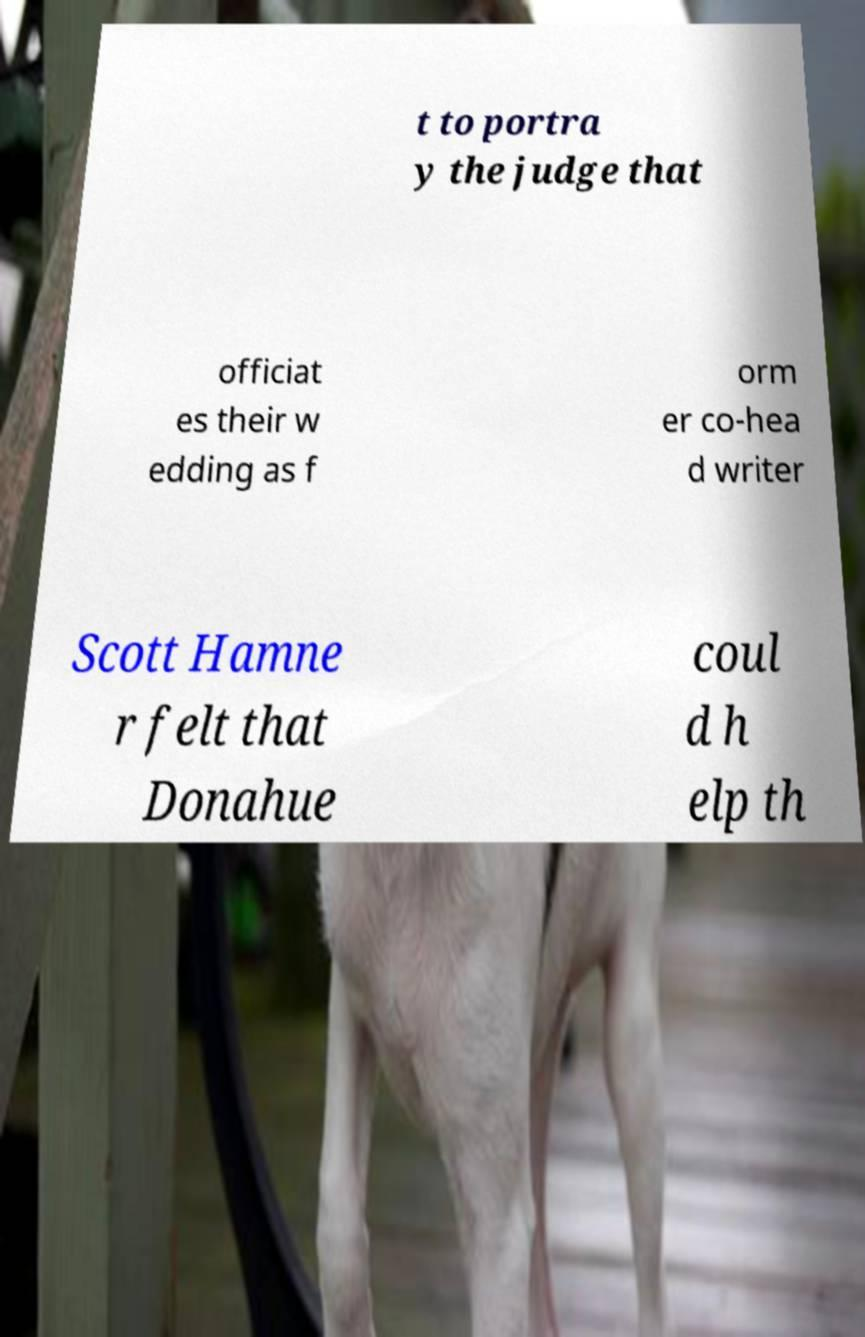Could you assist in decoding the text presented in this image and type it out clearly? t to portra y the judge that officiat es their w edding as f orm er co-hea d writer Scott Hamne r felt that Donahue coul d h elp th 